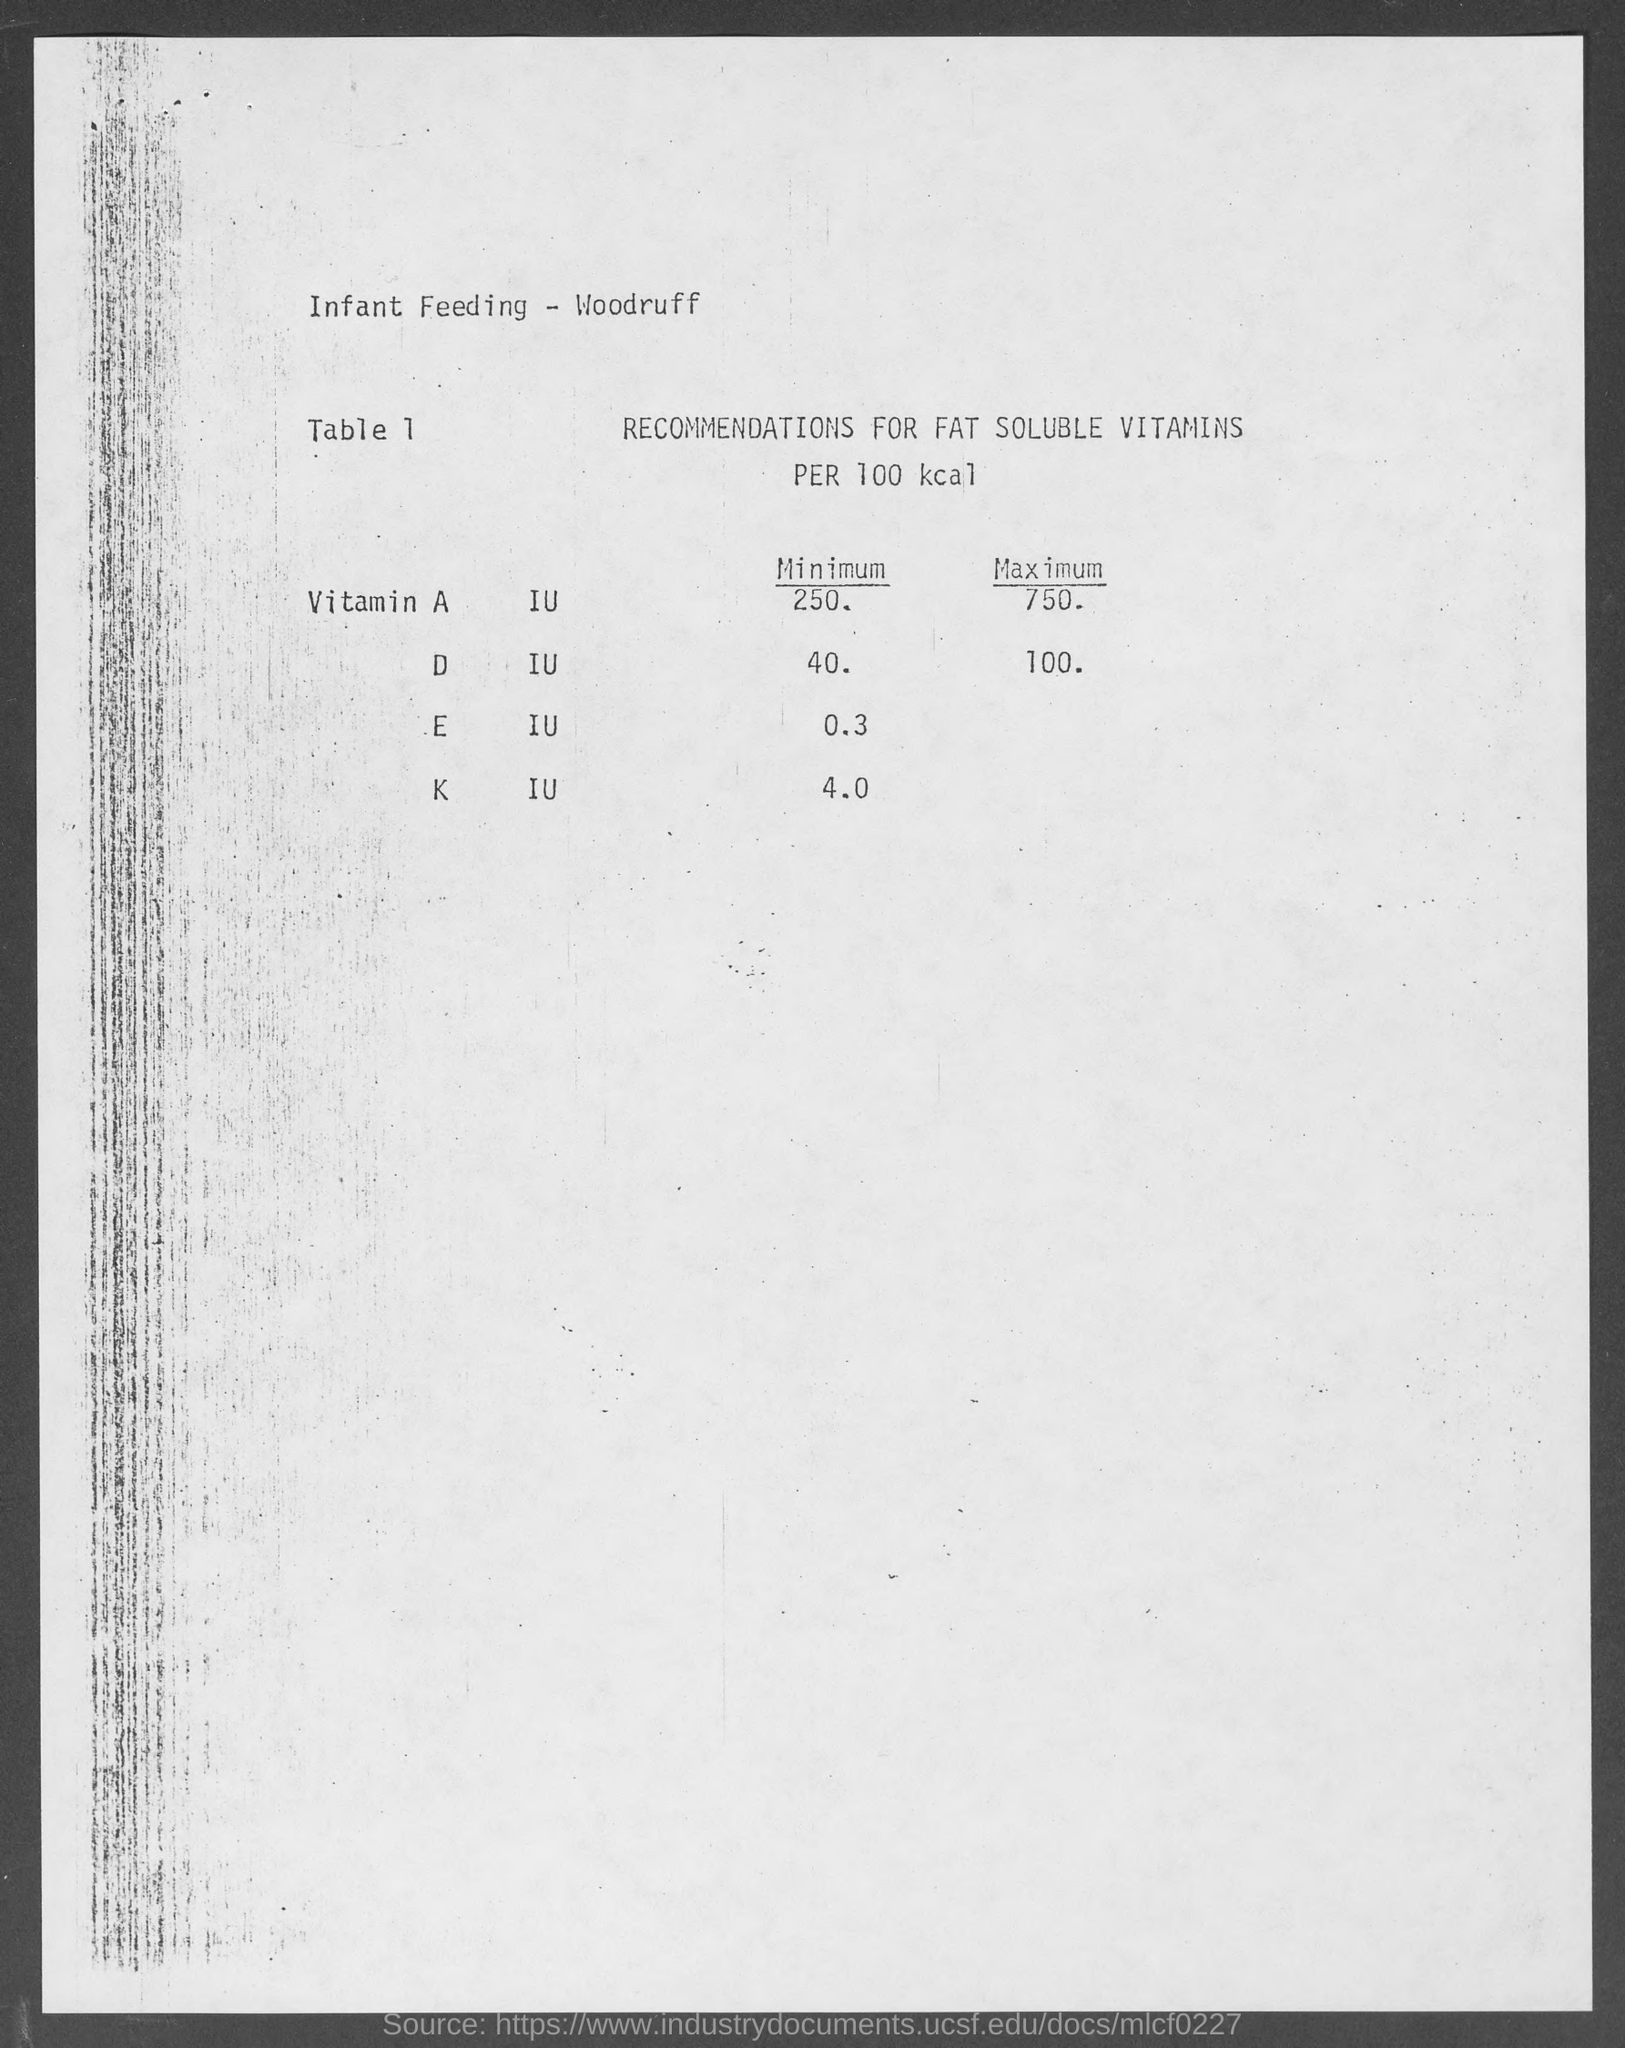What is the title of the table 1?
Make the answer very short. RECOMMENDATIONS FOR FAT SOLUBLE VITAMINS PER 100 kcal. 